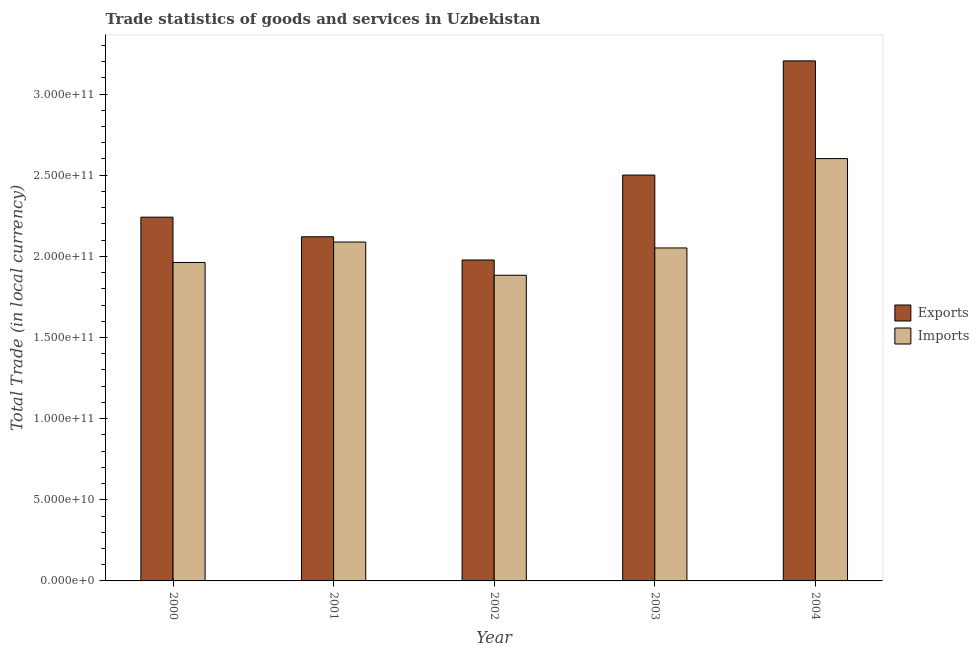How many groups of bars are there?
Your answer should be compact. 5. Are the number of bars per tick equal to the number of legend labels?
Your answer should be compact. Yes. How many bars are there on the 4th tick from the left?
Give a very brief answer. 2. In how many cases, is the number of bars for a given year not equal to the number of legend labels?
Make the answer very short. 0. What is the export of goods and services in 2003?
Your response must be concise. 2.50e+11. Across all years, what is the maximum imports of goods and services?
Your answer should be very brief. 2.60e+11. Across all years, what is the minimum export of goods and services?
Your answer should be compact. 1.98e+11. In which year was the imports of goods and services maximum?
Ensure brevity in your answer.  2004. In which year was the export of goods and services minimum?
Your answer should be very brief. 2002. What is the total export of goods and services in the graph?
Your answer should be compact. 1.20e+12. What is the difference between the export of goods and services in 2001 and that in 2004?
Your response must be concise. -1.08e+11. What is the difference between the imports of goods and services in 2001 and the export of goods and services in 2004?
Ensure brevity in your answer.  -5.14e+1. What is the average imports of goods and services per year?
Your response must be concise. 2.12e+11. In how many years, is the imports of goods and services greater than 80000000000 LCU?
Offer a very short reply. 5. What is the ratio of the export of goods and services in 2002 to that in 2004?
Your answer should be very brief. 0.62. Is the difference between the imports of goods and services in 2000 and 2001 greater than the difference between the export of goods and services in 2000 and 2001?
Keep it short and to the point. No. What is the difference between the highest and the second highest export of goods and services?
Offer a very short reply. 7.04e+1. What is the difference between the highest and the lowest export of goods and services?
Your answer should be compact. 1.23e+11. What does the 2nd bar from the left in 2003 represents?
Give a very brief answer. Imports. What does the 1st bar from the right in 2002 represents?
Ensure brevity in your answer.  Imports. How many bars are there?
Provide a succinct answer. 10. Are all the bars in the graph horizontal?
Offer a very short reply. No. What is the difference between two consecutive major ticks on the Y-axis?
Keep it short and to the point. 5.00e+1. Are the values on the major ticks of Y-axis written in scientific E-notation?
Keep it short and to the point. Yes. Does the graph contain any zero values?
Your answer should be compact. No. Where does the legend appear in the graph?
Provide a short and direct response. Center right. What is the title of the graph?
Give a very brief answer. Trade statistics of goods and services in Uzbekistan. What is the label or title of the X-axis?
Keep it short and to the point. Year. What is the label or title of the Y-axis?
Give a very brief answer. Total Trade (in local currency). What is the Total Trade (in local currency) in Exports in 2000?
Your answer should be very brief. 2.24e+11. What is the Total Trade (in local currency) in Imports in 2000?
Your answer should be very brief. 1.96e+11. What is the Total Trade (in local currency) of Exports in 2001?
Give a very brief answer. 2.12e+11. What is the Total Trade (in local currency) of Imports in 2001?
Offer a very short reply. 2.09e+11. What is the Total Trade (in local currency) of Exports in 2002?
Provide a short and direct response. 1.98e+11. What is the Total Trade (in local currency) in Imports in 2002?
Your answer should be compact. 1.88e+11. What is the Total Trade (in local currency) in Exports in 2003?
Offer a very short reply. 2.50e+11. What is the Total Trade (in local currency) of Imports in 2003?
Offer a very short reply. 2.05e+11. What is the Total Trade (in local currency) of Exports in 2004?
Give a very brief answer. 3.20e+11. What is the Total Trade (in local currency) in Imports in 2004?
Make the answer very short. 2.60e+11. Across all years, what is the maximum Total Trade (in local currency) of Exports?
Make the answer very short. 3.20e+11. Across all years, what is the maximum Total Trade (in local currency) of Imports?
Your answer should be very brief. 2.60e+11. Across all years, what is the minimum Total Trade (in local currency) in Exports?
Keep it short and to the point. 1.98e+11. Across all years, what is the minimum Total Trade (in local currency) of Imports?
Make the answer very short. 1.88e+11. What is the total Total Trade (in local currency) in Exports in the graph?
Provide a short and direct response. 1.20e+12. What is the total Total Trade (in local currency) of Imports in the graph?
Provide a succinct answer. 1.06e+12. What is the difference between the Total Trade (in local currency) of Exports in 2000 and that in 2001?
Give a very brief answer. 1.21e+1. What is the difference between the Total Trade (in local currency) of Imports in 2000 and that in 2001?
Ensure brevity in your answer.  -1.26e+1. What is the difference between the Total Trade (in local currency) in Exports in 2000 and that in 2002?
Your response must be concise. 2.64e+1. What is the difference between the Total Trade (in local currency) of Imports in 2000 and that in 2002?
Your response must be concise. 7.88e+09. What is the difference between the Total Trade (in local currency) of Exports in 2000 and that in 2003?
Ensure brevity in your answer.  -2.59e+1. What is the difference between the Total Trade (in local currency) of Imports in 2000 and that in 2003?
Offer a terse response. -8.95e+09. What is the difference between the Total Trade (in local currency) in Exports in 2000 and that in 2004?
Offer a very short reply. -9.63e+1. What is the difference between the Total Trade (in local currency) in Imports in 2000 and that in 2004?
Your response must be concise. -6.40e+1. What is the difference between the Total Trade (in local currency) of Exports in 2001 and that in 2002?
Your response must be concise. 1.43e+1. What is the difference between the Total Trade (in local currency) in Imports in 2001 and that in 2002?
Make the answer very short. 2.05e+1. What is the difference between the Total Trade (in local currency) of Exports in 2001 and that in 2003?
Your answer should be compact. -3.80e+1. What is the difference between the Total Trade (in local currency) of Imports in 2001 and that in 2003?
Offer a terse response. 3.64e+09. What is the difference between the Total Trade (in local currency) in Exports in 2001 and that in 2004?
Give a very brief answer. -1.08e+11. What is the difference between the Total Trade (in local currency) in Imports in 2001 and that in 2004?
Make the answer very short. -5.14e+1. What is the difference between the Total Trade (in local currency) of Exports in 2002 and that in 2003?
Your answer should be compact. -5.23e+1. What is the difference between the Total Trade (in local currency) of Imports in 2002 and that in 2003?
Provide a succinct answer. -1.68e+1. What is the difference between the Total Trade (in local currency) of Exports in 2002 and that in 2004?
Keep it short and to the point. -1.23e+11. What is the difference between the Total Trade (in local currency) of Imports in 2002 and that in 2004?
Make the answer very short. -7.19e+1. What is the difference between the Total Trade (in local currency) in Exports in 2003 and that in 2004?
Provide a short and direct response. -7.04e+1. What is the difference between the Total Trade (in local currency) in Imports in 2003 and that in 2004?
Your answer should be very brief. -5.51e+1. What is the difference between the Total Trade (in local currency) in Exports in 2000 and the Total Trade (in local currency) in Imports in 2001?
Your answer should be compact. 1.53e+1. What is the difference between the Total Trade (in local currency) in Exports in 2000 and the Total Trade (in local currency) in Imports in 2002?
Your answer should be compact. 3.58e+1. What is the difference between the Total Trade (in local currency) in Exports in 2000 and the Total Trade (in local currency) in Imports in 2003?
Offer a terse response. 1.90e+1. What is the difference between the Total Trade (in local currency) of Exports in 2000 and the Total Trade (in local currency) of Imports in 2004?
Keep it short and to the point. -3.61e+1. What is the difference between the Total Trade (in local currency) of Exports in 2001 and the Total Trade (in local currency) of Imports in 2002?
Your response must be concise. 2.37e+1. What is the difference between the Total Trade (in local currency) in Exports in 2001 and the Total Trade (in local currency) in Imports in 2003?
Give a very brief answer. 6.89e+09. What is the difference between the Total Trade (in local currency) of Exports in 2001 and the Total Trade (in local currency) of Imports in 2004?
Your answer should be compact. -4.82e+1. What is the difference between the Total Trade (in local currency) of Exports in 2002 and the Total Trade (in local currency) of Imports in 2003?
Give a very brief answer. -7.42e+09. What is the difference between the Total Trade (in local currency) of Exports in 2002 and the Total Trade (in local currency) of Imports in 2004?
Offer a terse response. -6.25e+1. What is the difference between the Total Trade (in local currency) of Exports in 2003 and the Total Trade (in local currency) of Imports in 2004?
Provide a short and direct response. -1.01e+1. What is the average Total Trade (in local currency) in Exports per year?
Keep it short and to the point. 2.41e+11. What is the average Total Trade (in local currency) in Imports per year?
Provide a short and direct response. 2.12e+11. In the year 2000, what is the difference between the Total Trade (in local currency) in Exports and Total Trade (in local currency) in Imports?
Offer a very short reply. 2.79e+1. In the year 2001, what is the difference between the Total Trade (in local currency) in Exports and Total Trade (in local currency) in Imports?
Ensure brevity in your answer.  3.25e+09. In the year 2002, what is the difference between the Total Trade (in local currency) in Exports and Total Trade (in local currency) in Imports?
Give a very brief answer. 9.41e+09. In the year 2003, what is the difference between the Total Trade (in local currency) of Exports and Total Trade (in local currency) of Imports?
Your answer should be compact. 4.49e+1. In the year 2004, what is the difference between the Total Trade (in local currency) in Exports and Total Trade (in local currency) in Imports?
Your answer should be very brief. 6.02e+1. What is the ratio of the Total Trade (in local currency) of Exports in 2000 to that in 2001?
Offer a terse response. 1.06. What is the ratio of the Total Trade (in local currency) of Imports in 2000 to that in 2001?
Keep it short and to the point. 0.94. What is the ratio of the Total Trade (in local currency) in Exports in 2000 to that in 2002?
Your answer should be very brief. 1.13. What is the ratio of the Total Trade (in local currency) in Imports in 2000 to that in 2002?
Offer a terse response. 1.04. What is the ratio of the Total Trade (in local currency) of Exports in 2000 to that in 2003?
Offer a terse response. 0.9. What is the ratio of the Total Trade (in local currency) of Imports in 2000 to that in 2003?
Your response must be concise. 0.96. What is the ratio of the Total Trade (in local currency) of Exports in 2000 to that in 2004?
Your answer should be very brief. 0.7. What is the ratio of the Total Trade (in local currency) in Imports in 2000 to that in 2004?
Provide a succinct answer. 0.75. What is the ratio of the Total Trade (in local currency) in Exports in 2001 to that in 2002?
Your answer should be compact. 1.07. What is the ratio of the Total Trade (in local currency) in Imports in 2001 to that in 2002?
Ensure brevity in your answer.  1.11. What is the ratio of the Total Trade (in local currency) in Exports in 2001 to that in 2003?
Make the answer very short. 0.85. What is the ratio of the Total Trade (in local currency) of Imports in 2001 to that in 2003?
Your answer should be very brief. 1.02. What is the ratio of the Total Trade (in local currency) in Exports in 2001 to that in 2004?
Your response must be concise. 0.66. What is the ratio of the Total Trade (in local currency) in Imports in 2001 to that in 2004?
Offer a very short reply. 0.8. What is the ratio of the Total Trade (in local currency) of Exports in 2002 to that in 2003?
Make the answer very short. 0.79. What is the ratio of the Total Trade (in local currency) of Imports in 2002 to that in 2003?
Offer a terse response. 0.92. What is the ratio of the Total Trade (in local currency) of Exports in 2002 to that in 2004?
Ensure brevity in your answer.  0.62. What is the ratio of the Total Trade (in local currency) of Imports in 2002 to that in 2004?
Provide a succinct answer. 0.72. What is the ratio of the Total Trade (in local currency) in Exports in 2003 to that in 2004?
Provide a short and direct response. 0.78. What is the ratio of the Total Trade (in local currency) of Imports in 2003 to that in 2004?
Ensure brevity in your answer.  0.79. What is the difference between the highest and the second highest Total Trade (in local currency) of Exports?
Your answer should be very brief. 7.04e+1. What is the difference between the highest and the second highest Total Trade (in local currency) in Imports?
Offer a very short reply. 5.14e+1. What is the difference between the highest and the lowest Total Trade (in local currency) in Exports?
Your response must be concise. 1.23e+11. What is the difference between the highest and the lowest Total Trade (in local currency) of Imports?
Make the answer very short. 7.19e+1. 